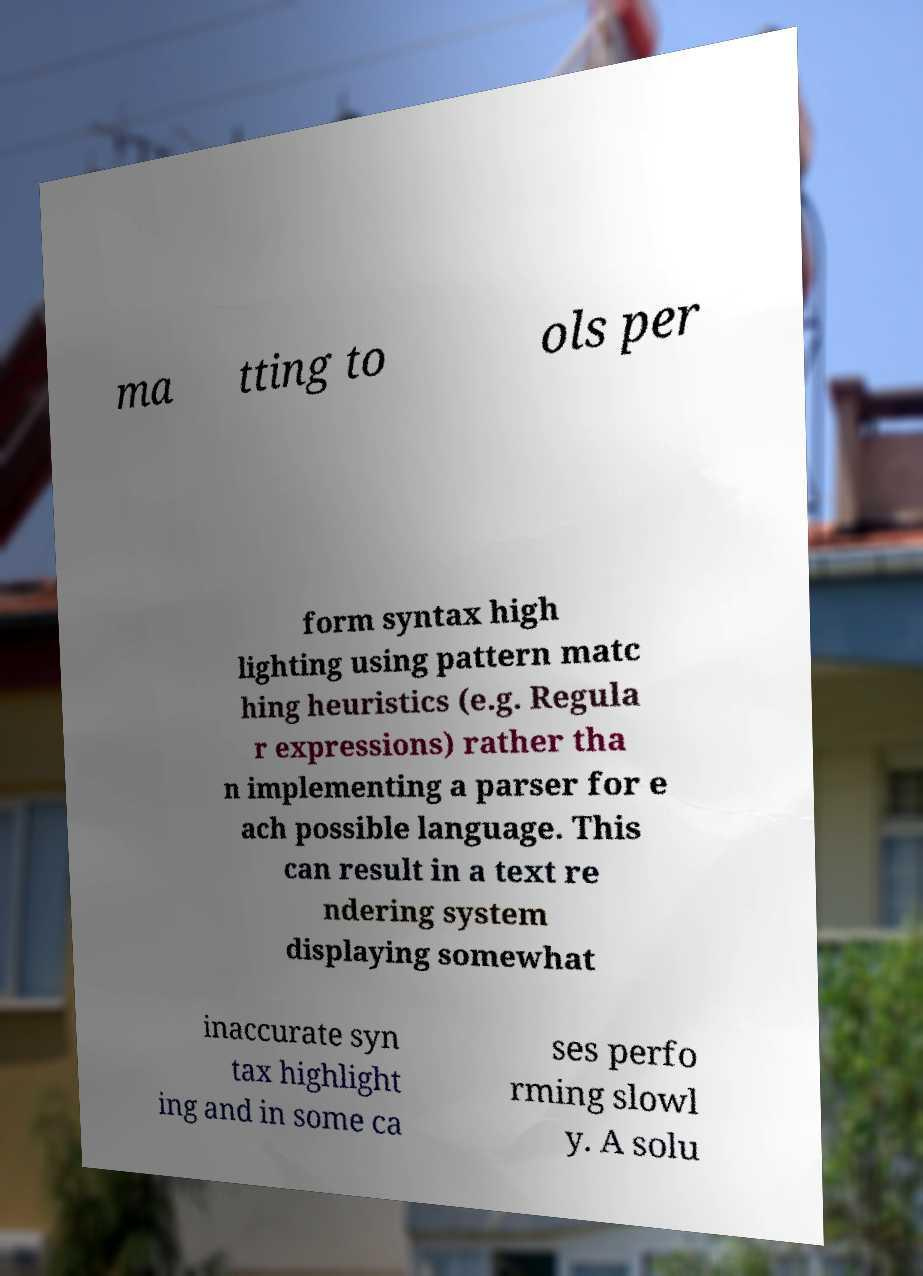Please read and relay the text visible in this image. What does it say? ma tting to ols per form syntax high lighting using pattern matc hing heuristics (e.g. Regula r expressions) rather tha n implementing a parser for e ach possible language. This can result in a text re ndering system displaying somewhat inaccurate syn tax highlight ing and in some ca ses perfo rming slowl y. A solu 